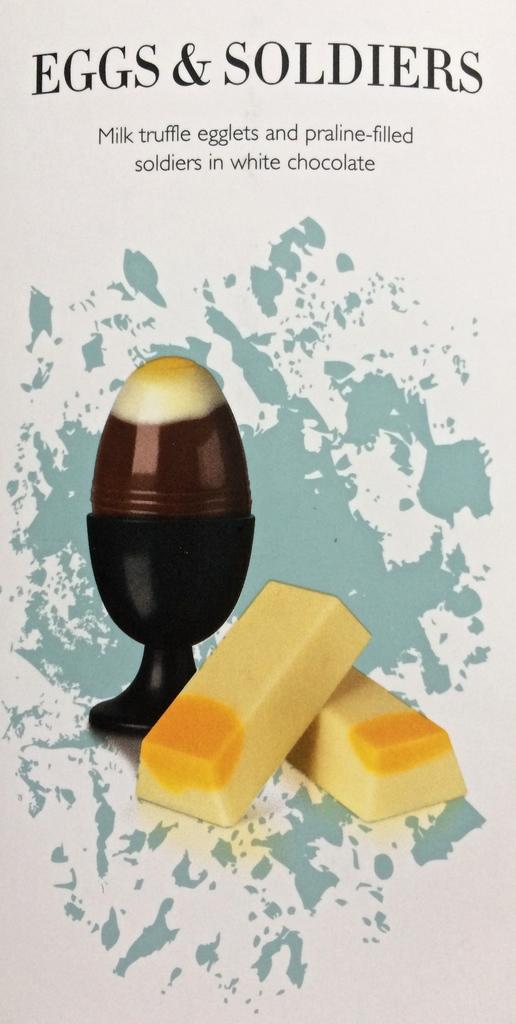What type of image is being described? The image appears to be a poster. What is the main subject of the poster? There is an egg in a cup on the poster. Are there any other elements on the poster besides the egg? Yes, there are two soldiers depicted beside the egg. What type of park is shown in the background of the poster? There is no park visible in the image; it only features an egg in a cup and two soldiers. What type of collar is the egg wearing in the image? The egg is not wearing a collar, as it is an inanimate object and does not have the ability to wear clothing or accessories. 